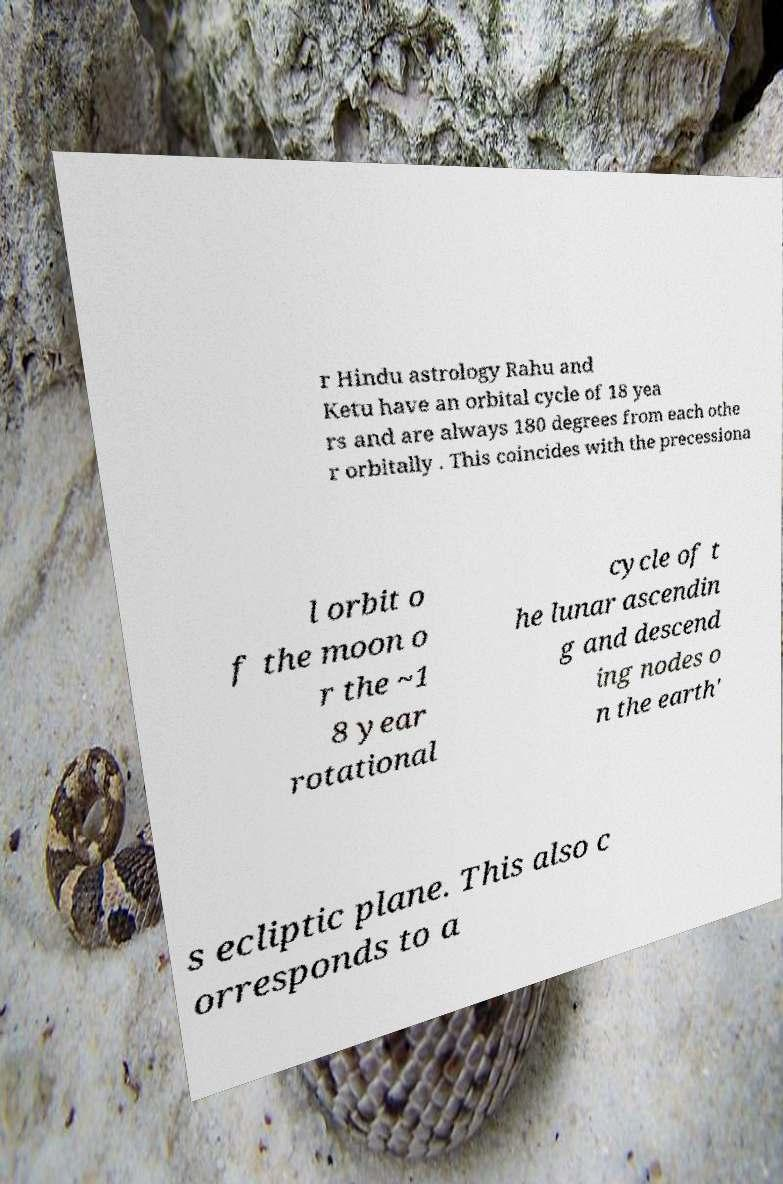What messages or text are displayed in this image? I need them in a readable, typed format. r Hindu astrology Rahu and Ketu have an orbital cycle of 18 yea rs and are always 180 degrees from each othe r orbitally . This coincides with the precessiona l orbit o f the moon o r the ~1 8 year rotational cycle of t he lunar ascendin g and descend ing nodes o n the earth' s ecliptic plane. This also c orresponds to a 